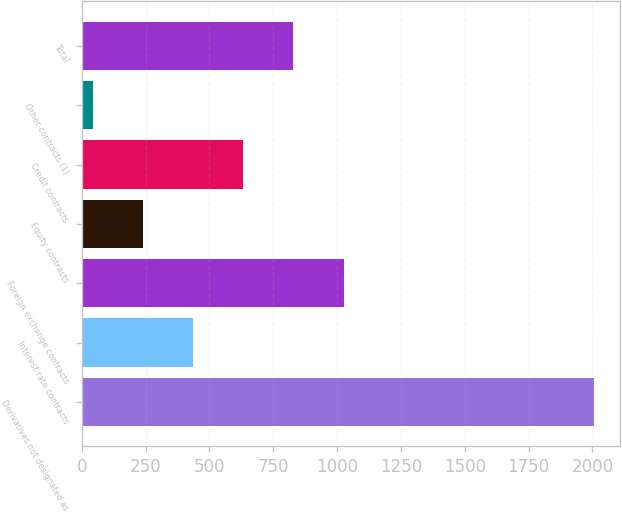<chart> <loc_0><loc_0><loc_500><loc_500><bar_chart><fcel>Derivatives not designated as<fcel>Interest rate contracts<fcel>Foreign exchange contracts<fcel>Equity contracts<fcel>Credit contracts<fcel>Other contracts (1)<fcel>Total<nl><fcel>2008<fcel>436.16<fcel>1025.6<fcel>239.68<fcel>632.64<fcel>43.2<fcel>829.12<nl></chart> 